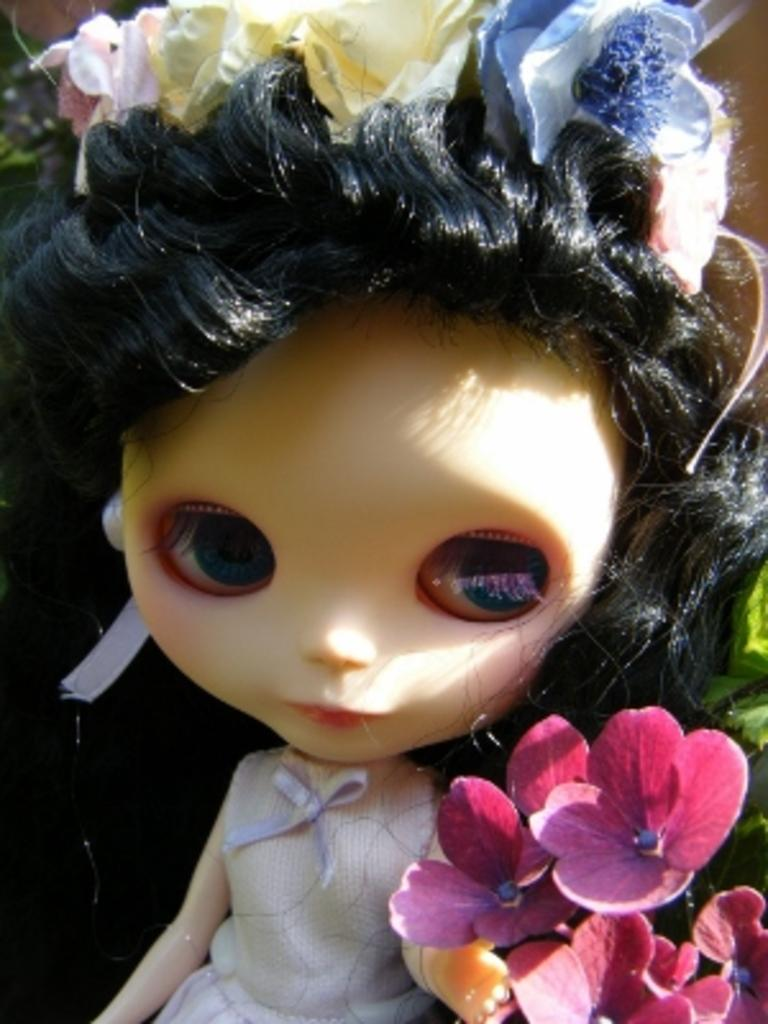What is the main subject in the center of the image? There is a doll in the center of the image. What other objects or elements can be seen on the right side of the image? There are flowers on the right side of the image. What impulse can be seen running across the image? There is no impulse or running figure present in the image. 